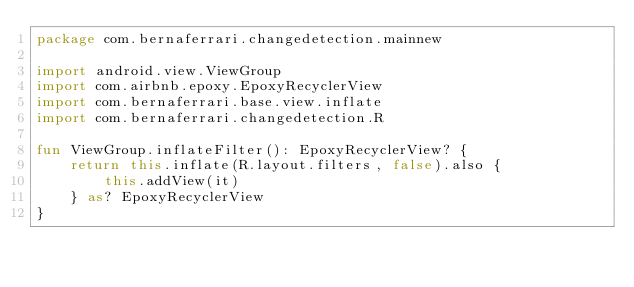Convert code to text. <code><loc_0><loc_0><loc_500><loc_500><_Kotlin_>package com.bernaferrari.changedetection.mainnew

import android.view.ViewGroup
import com.airbnb.epoxy.EpoxyRecyclerView
import com.bernaferrari.base.view.inflate
import com.bernaferrari.changedetection.R

fun ViewGroup.inflateFilter(): EpoxyRecyclerView? {
    return this.inflate(R.layout.filters, false).also {
        this.addView(it)
    } as? EpoxyRecyclerView
}</code> 